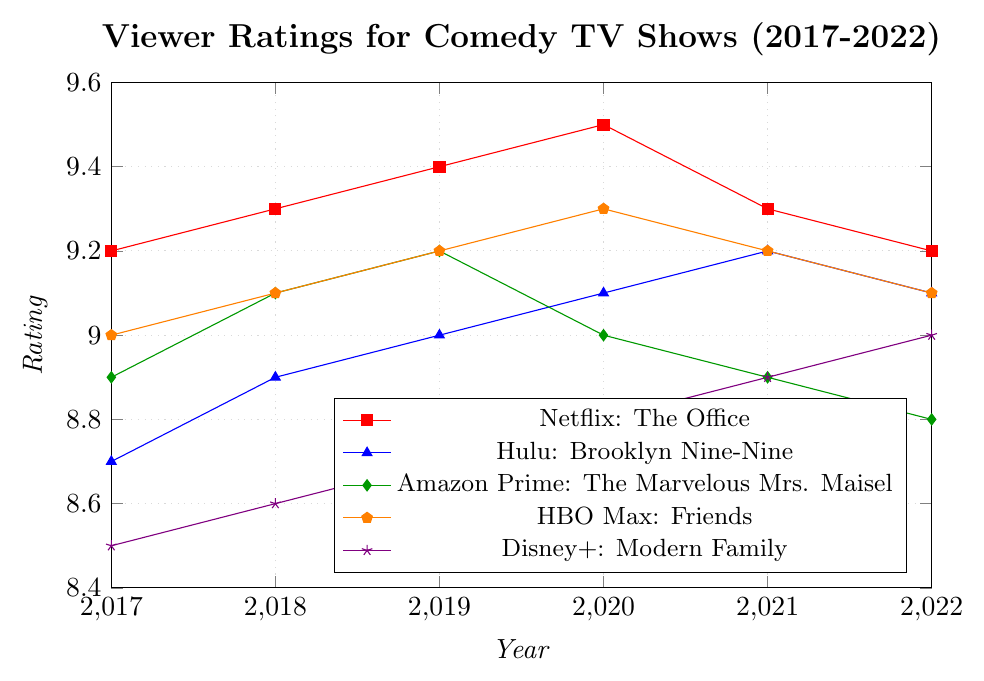What show had the highest viewer rating in 2020? According to the figure, the highest point on the y-axis for 2020 should represent the highest rating. The plot shows that Netflix: The Office had the highest rating in 2020.
Answer: Netflix: The Office How did the ratings for Amazon Prime: The Marvelous Mrs. Maisel change from 2019 to 2020? To observe the change, compare the ratings in 2019 and 2020. In 2019, the rating was 9.2, and in 2020 it dropped to 9.0.
Answer: The rating decreased Compare the rating trends of HBO Max: Friends and Disney+: Modern Family. Observe the lines for HBO Max and Disney+; HBO Max: Friends starts at 9.0 in 2017 and ends at 9.1 in 2022, showing a slight increase. Disney+: Modern Family starts at 8.5 in 2017 and increases more uniformly, ending at 9.0 in 2022.
Answer: Both increased, but Disney+: Modern Family had a more uniform increase What year did Hulu: Brooklyn Nine-Nine have the highest rating? Check the peaks of the Hulu: Brooklyn Nine-Nine line. The highest point is in 2021 with a rating of 9.2.
Answer: 2021 Did any show have a rating drop from 2021 to 2022? Compare the ratings from 2021 to 2022 for each show in the plot. Both Amazon Prime: The Marvelous Mrs. Maisel and Netflix: The Office had a drop.
Answer: Yes What is the difference in ratings between Netflix: The Office and Disney+: Modern Family in 2020? Look at the ratings in 2020 for both shows. Netflix: The Office has a rating of 9.5 and Disney+: Modern Family has a rating of 8.8. Subtract the lower rating from the higher one: 9.5 - 8.8.
Answer: 0.7 What is the overall trend for Netflix: The Office from 2017 to 2022? Observe the direction of the Netflix: The Office line from the start (2017) to the end (2022). It shows an upward trend until 2020, then a slight decline afterward.
Answer: Upward until 2020, then downward Which show had the lowest rating in 2017? Inspect the y-axis value at 2017 for each show. Hulu: Brooklyn Nine-Nine had the lowest rating among the shows listed.
Answer: Hulu: Brooklyn Nine-Nine 